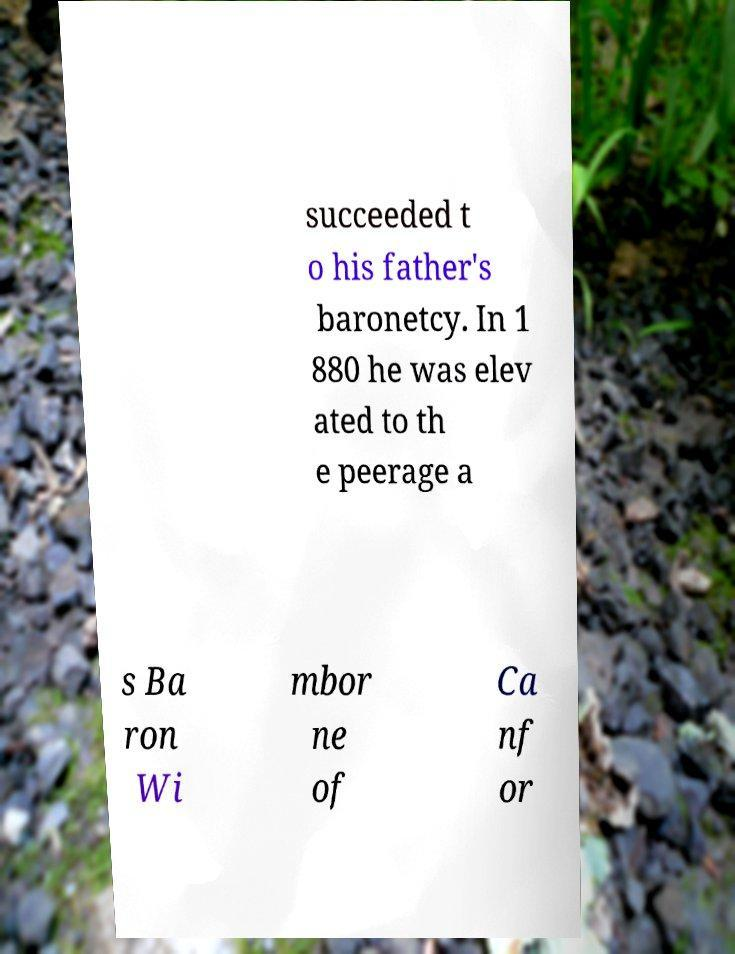Could you assist in decoding the text presented in this image and type it out clearly? succeeded t o his father's baronetcy. In 1 880 he was elev ated to th e peerage a s Ba ron Wi mbor ne of Ca nf or 